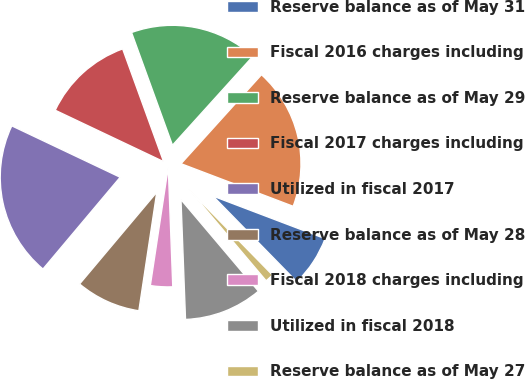Convert chart to OTSL. <chart><loc_0><loc_0><loc_500><loc_500><pie_chart><fcel>Reserve balance as of May 31<fcel>Fiscal 2016 charges including<fcel>Reserve balance as of May 29<fcel>Fiscal 2017 charges including<fcel>Utilized in fiscal 2017<fcel>Reserve balance as of May 28<fcel>Fiscal 2018 charges including<fcel>Utilized in fiscal 2018<fcel>Reserve balance as of May 27<nl><fcel>6.9%<fcel>19.08%<fcel>17.24%<fcel>12.41%<fcel>20.92%<fcel>8.74%<fcel>2.99%<fcel>10.57%<fcel>1.15%<nl></chart> 